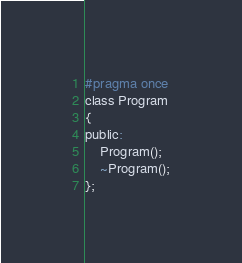Convert code to text. <code><loc_0><loc_0><loc_500><loc_500><_C_>#pragma once
class Program
{
public:
	Program();
	~Program();
};

</code> 